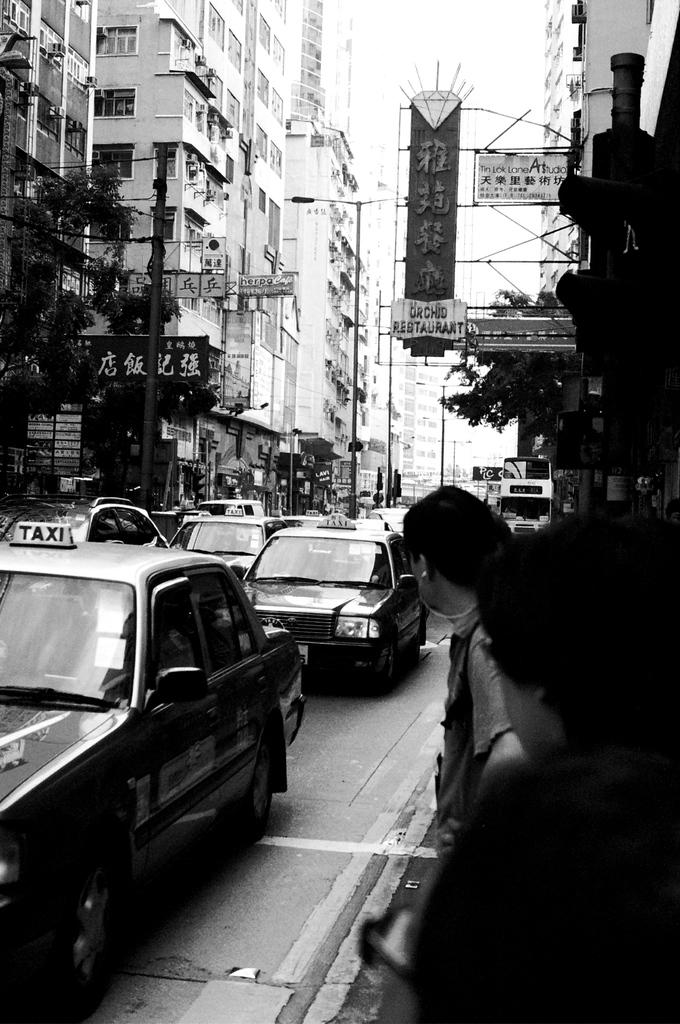<image>
Render a clear and concise summary of the photo. A busy street in an Asian city with Asian signs and a taxi. 